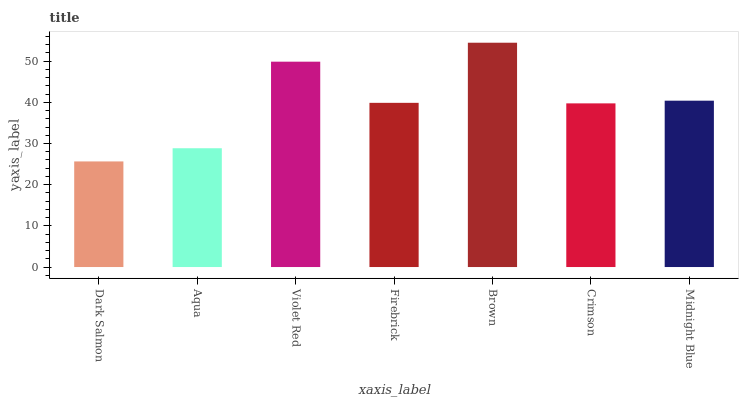Is Dark Salmon the minimum?
Answer yes or no. Yes. Is Brown the maximum?
Answer yes or no. Yes. Is Aqua the minimum?
Answer yes or no. No. Is Aqua the maximum?
Answer yes or no. No. Is Aqua greater than Dark Salmon?
Answer yes or no. Yes. Is Dark Salmon less than Aqua?
Answer yes or no. Yes. Is Dark Salmon greater than Aqua?
Answer yes or no. No. Is Aqua less than Dark Salmon?
Answer yes or no. No. Is Firebrick the high median?
Answer yes or no. Yes. Is Firebrick the low median?
Answer yes or no. Yes. Is Dark Salmon the high median?
Answer yes or no. No. Is Aqua the low median?
Answer yes or no. No. 